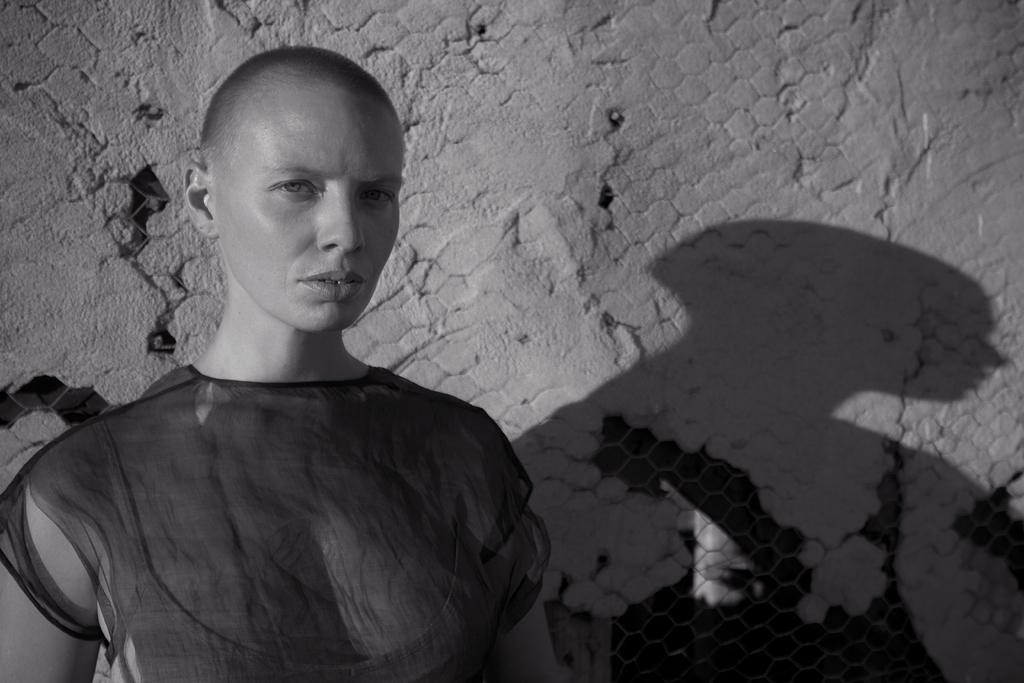What is the main subject in the front of the image? There is a person standing in the front of the image. What can be seen in the background of the image? There is a wall and a fence in the background of the image. Can you see any bats flying around the person in the image? There are no bats visible in the image. 